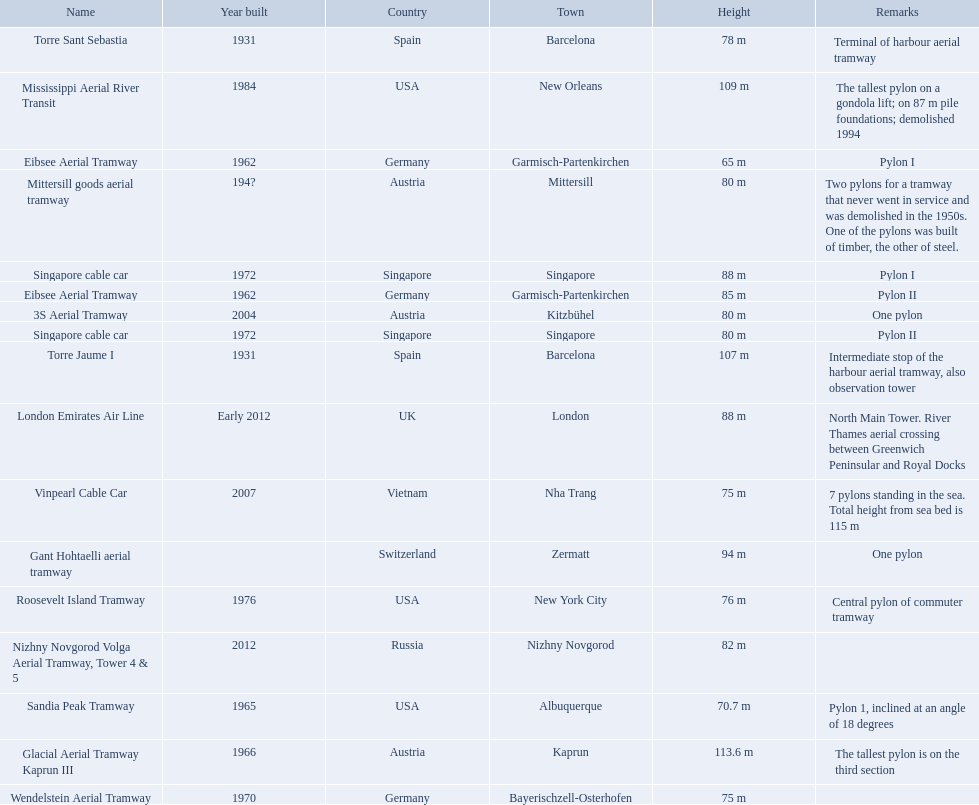How many aerial lift pylon's on the list are located in the usa? Mississippi Aerial River Transit, Roosevelt Island Tramway, Sandia Peak Tramway. Of the pylon's located in the usa how many were built after 1970? Mississippi Aerial River Transit, Roosevelt Island Tramway. Of the pylon's built after 1970 which is the tallest pylon on a gondola lift? Mississippi Aerial River Transit. How many meters is the tallest pylon on a gondola lift? 109 m. Which lift has the second highest height? Mississippi Aerial River Transit. What is the value of the height? 109 m. 